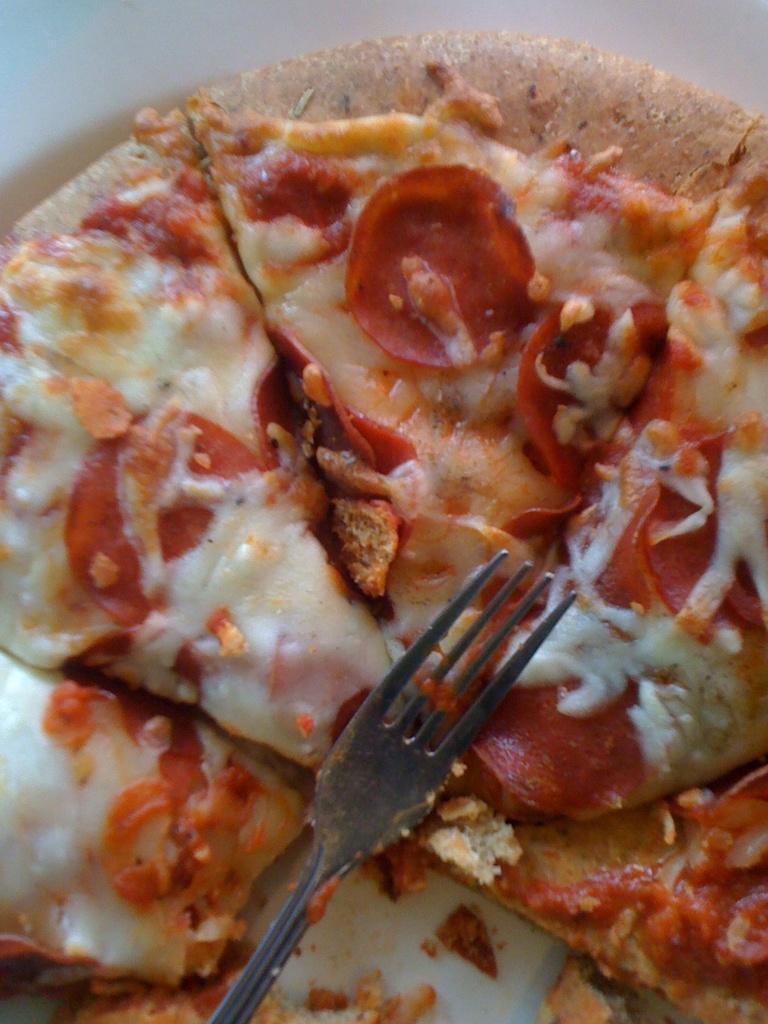In one or two sentences, can you explain what this image depicts? In this picture I can see fork on the pizza. 